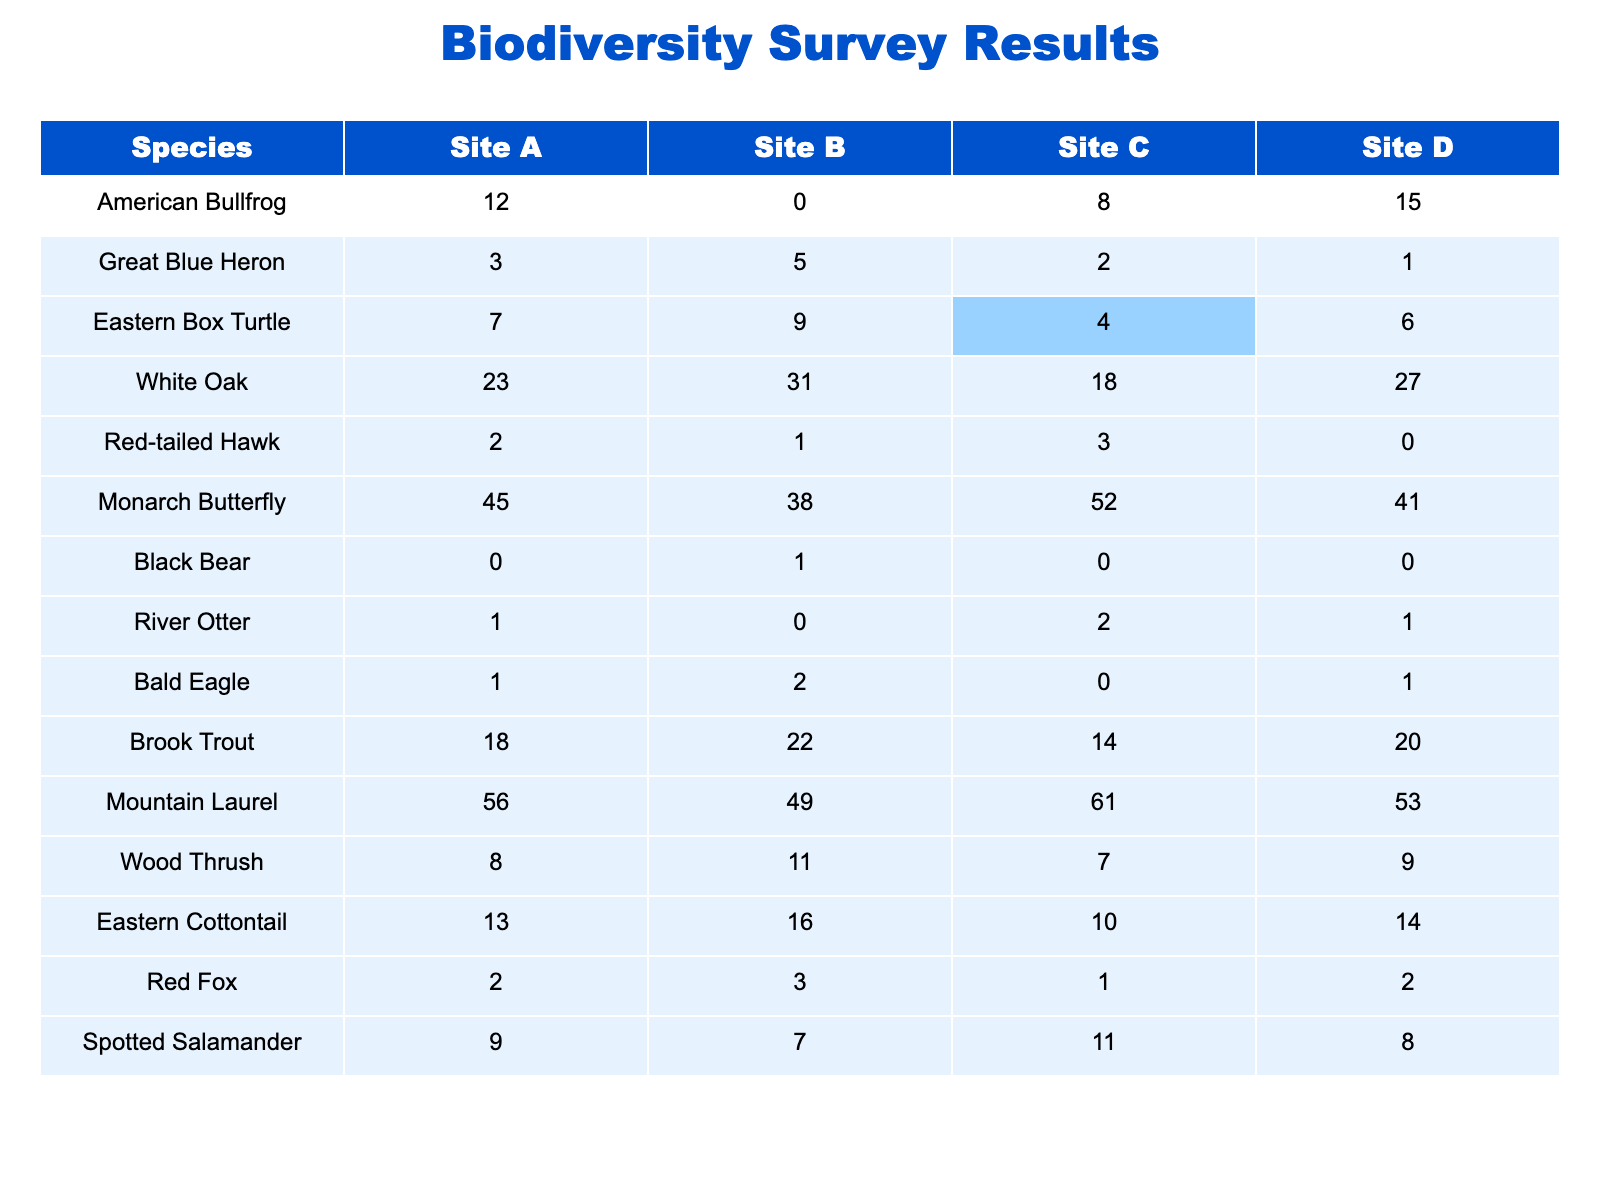What is the total number of American Bullfrogs observed across all sites? To find the total, I add the values from all sites: 12 (Site A) + 0 (Site B) + 8 (Site C) + 15 (Site D) = 35.
Answer: 35 Which site has the highest observed number of Monarch Butterflies? By comparing the counts, Site C has 52 Monarch Butterflies, which is higher than the counts from other sites (45, 38, and 41 respectively).
Answer: Site C What is the average number of White Oaks across all sites? The number of White Oaks at each site is: 23 (Site A), 31 (Site B), 18 (Site C), 27 (Site D). The average is calculated as (23 + 31 + 18 + 27) / 4 = 99 / 4 = 24.75.
Answer: 24.75 Is there a greater variety of species observed at Site B than at Site D? Count the distinct species recorded at each site. Site B has 12 distinct species, while Site D has 11. Thus, Site B has a greater variety.
Answer: Yes What is the difference in the number of Brook Trout observed between Site A and Site C? The counts of Brook Trout are 18 (Site A) and 14 (Site C). The difference is 18 - 14 = 4.
Answer: 4 Which species had the least observations at Site D? Looking at Site D’s data, the species with the fewest observations is the Red-tailed Hawk with 0 sightings.
Answer: Red-tailed Hawk If we sum the total counts of Eastern Box Turtles from all sites, what is the result? The counts for Eastern Box Turtles are: 7 (Site A) + 9 (Site B) + 4 (Site C) + 6 (Site D) = 26.
Answer: 26 Which species has more than 50 observations at any site? Scanning the table, the Monarch Butterfly (52 at Site C) and Mountain Laurel (61 at Site C) both exceed 50 observations.
Answer: Monarch Butterfly, Mountain Laurel How many more Eastern Cottontails were observed at Site B than at Site D? The counts are 16 (Site B) and 14 (Site D). The difference is 16 - 14 = 2.
Answer: 2 What percentage of the total number of Black Bears were observed at Site B? The total number of Black Bears is 1 (at Site B). Since this is the only observation, the percentage is (1/1)*100 = 100%.
Answer: 100% 